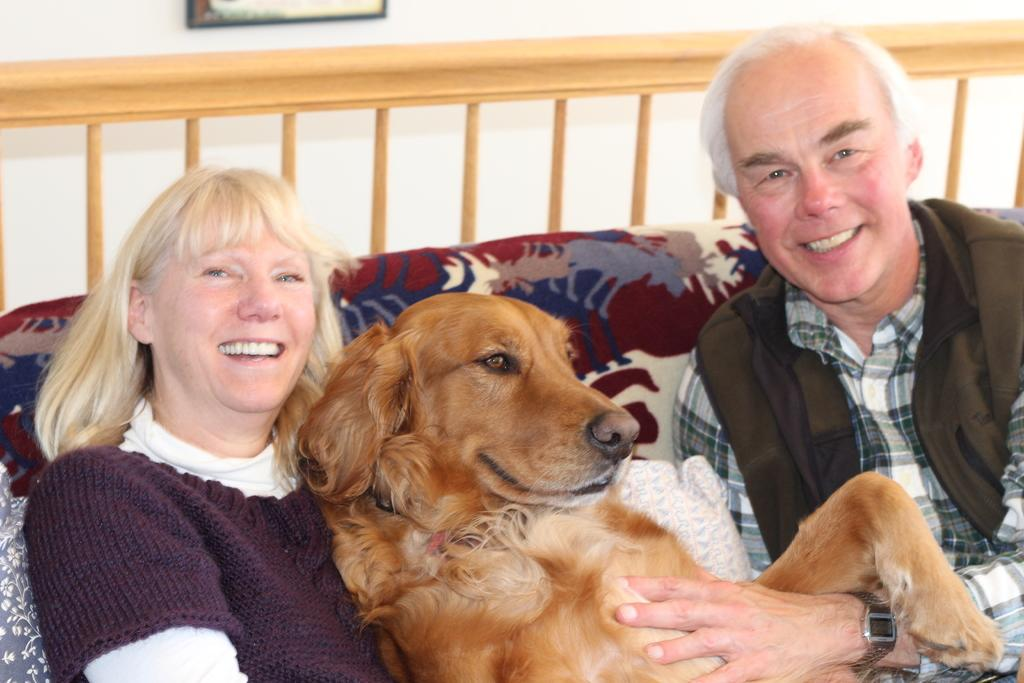What are the people in the image doing? The people in the image are sitting on a sofa and smiling. What else can be seen in the image besides the people? There is a dog in the image. Is there any decoration or object visible on the wall in the background? Yes, there is a frame on the wall in the background of the image. How many houses can be seen in the image? There are no houses visible in the image. What type of ants are crawling on the sofa in the image? There are no ants present in the image. 